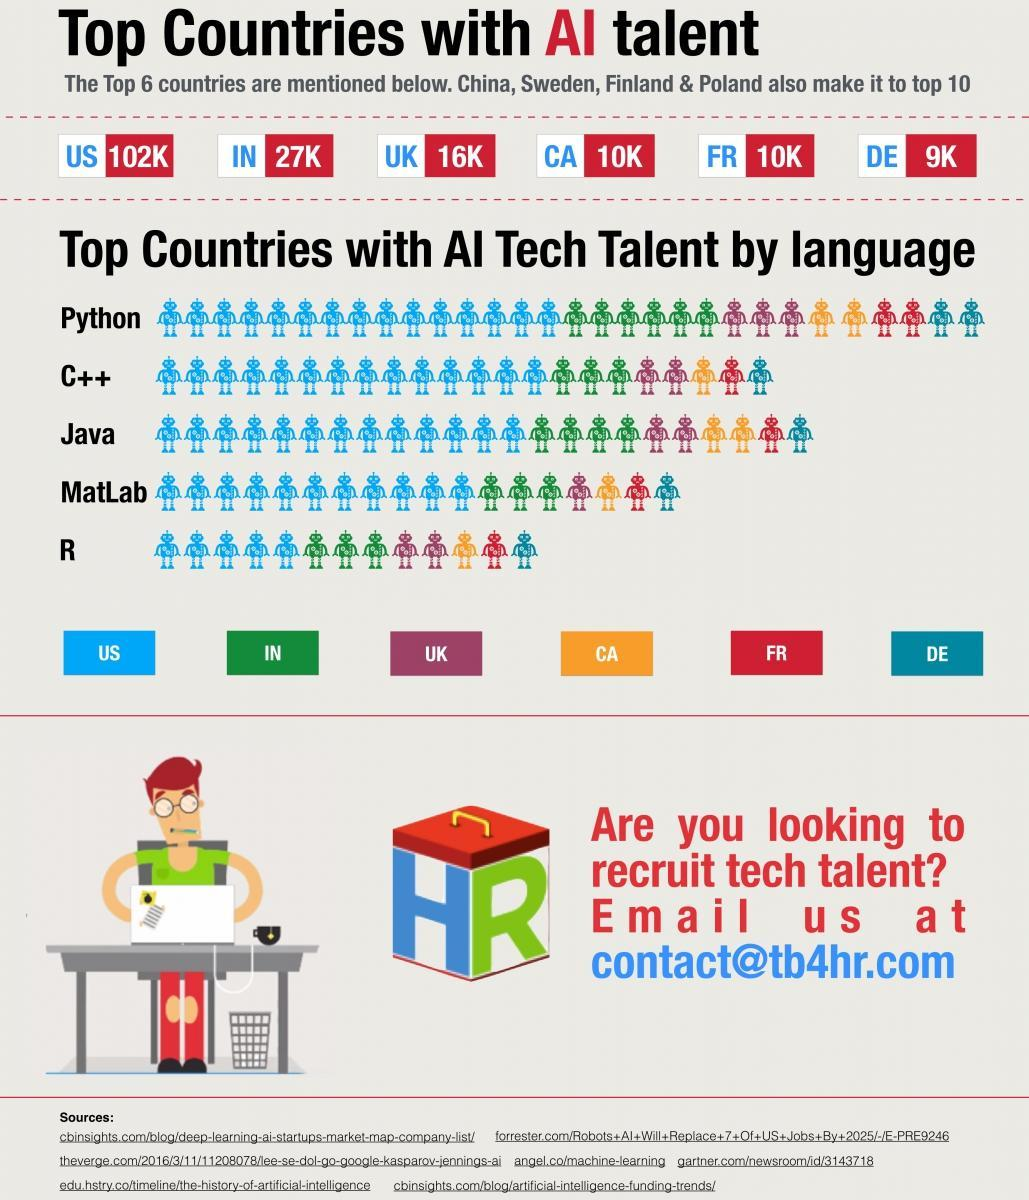Which country is least equipped with AI tech talent?
Answer the question with a short phrase. DE Which is the top most country with AI  tech talent? US Which is the most used AI language in these countries? Python Which is the least used AI language in these countries? R 